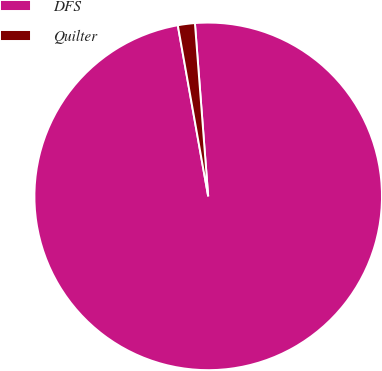<chart> <loc_0><loc_0><loc_500><loc_500><pie_chart><fcel>DFS<fcel>Quilter<nl><fcel>98.42%<fcel>1.58%<nl></chart> 